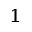<formula> <loc_0><loc_0><loc_500><loc_500>^ { 1 }</formula> 